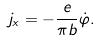Convert formula to latex. <formula><loc_0><loc_0><loc_500><loc_500>j _ { x } = - \frac { e } { \pi b } \dot { \varphi } .</formula> 